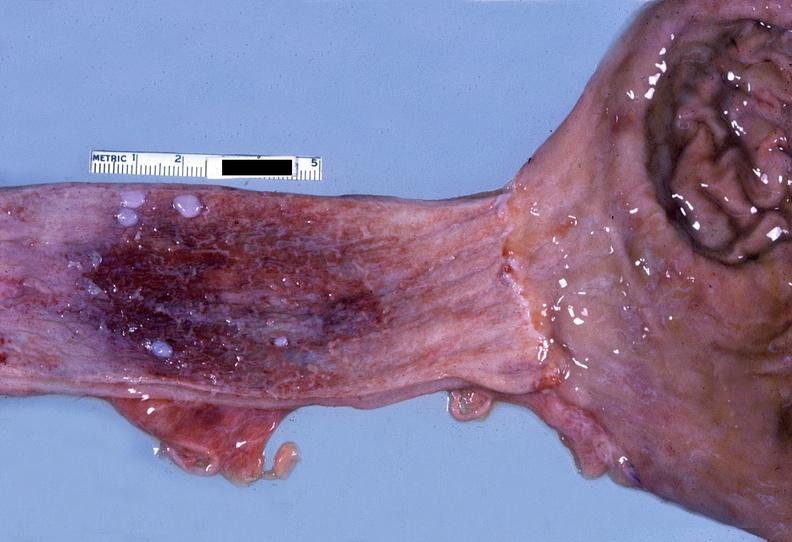s stein leventhal present?
Answer the question using a single word or phrase. No 